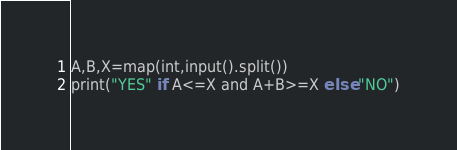Convert code to text. <code><loc_0><loc_0><loc_500><loc_500><_Python_>A,B,X=map(int,input().split())
print("YES" if A<=X and A+B>=X else "NO")</code> 